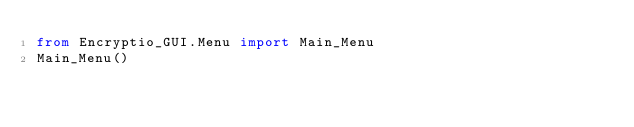Convert code to text. <code><loc_0><loc_0><loc_500><loc_500><_Python_>from Encryptio_GUI.Menu import Main_Menu
Main_Menu()
</code> 